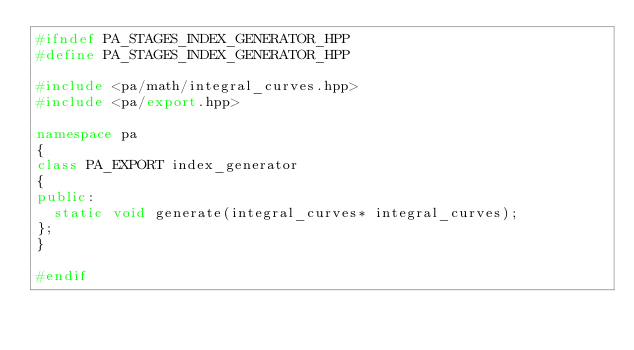<code> <loc_0><loc_0><loc_500><loc_500><_C++_>#ifndef PA_STAGES_INDEX_GENERATOR_HPP
#define PA_STAGES_INDEX_GENERATOR_HPP

#include <pa/math/integral_curves.hpp>
#include <pa/export.hpp>

namespace pa
{
class PA_EXPORT index_generator
{
public:
  static void generate(integral_curves* integral_curves);
};
}

#endif</code> 